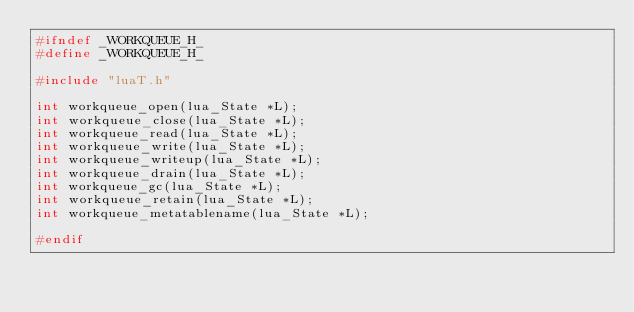<code> <loc_0><loc_0><loc_500><loc_500><_C_>#ifndef _WORKQUEUE_H_
#define _WORKQUEUE_H_

#include "luaT.h"

int workqueue_open(lua_State *L);
int workqueue_close(lua_State *L);
int workqueue_read(lua_State *L);
int workqueue_write(lua_State *L);
int workqueue_writeup(lua_State *L);
int workqueue_drain(lua_State *L);
int workqueue_gc(lua_State *L);
int workqueue_retain(lua_State *L);
int workqueue_metatablename(lua_State *L);

#endif
</code> 